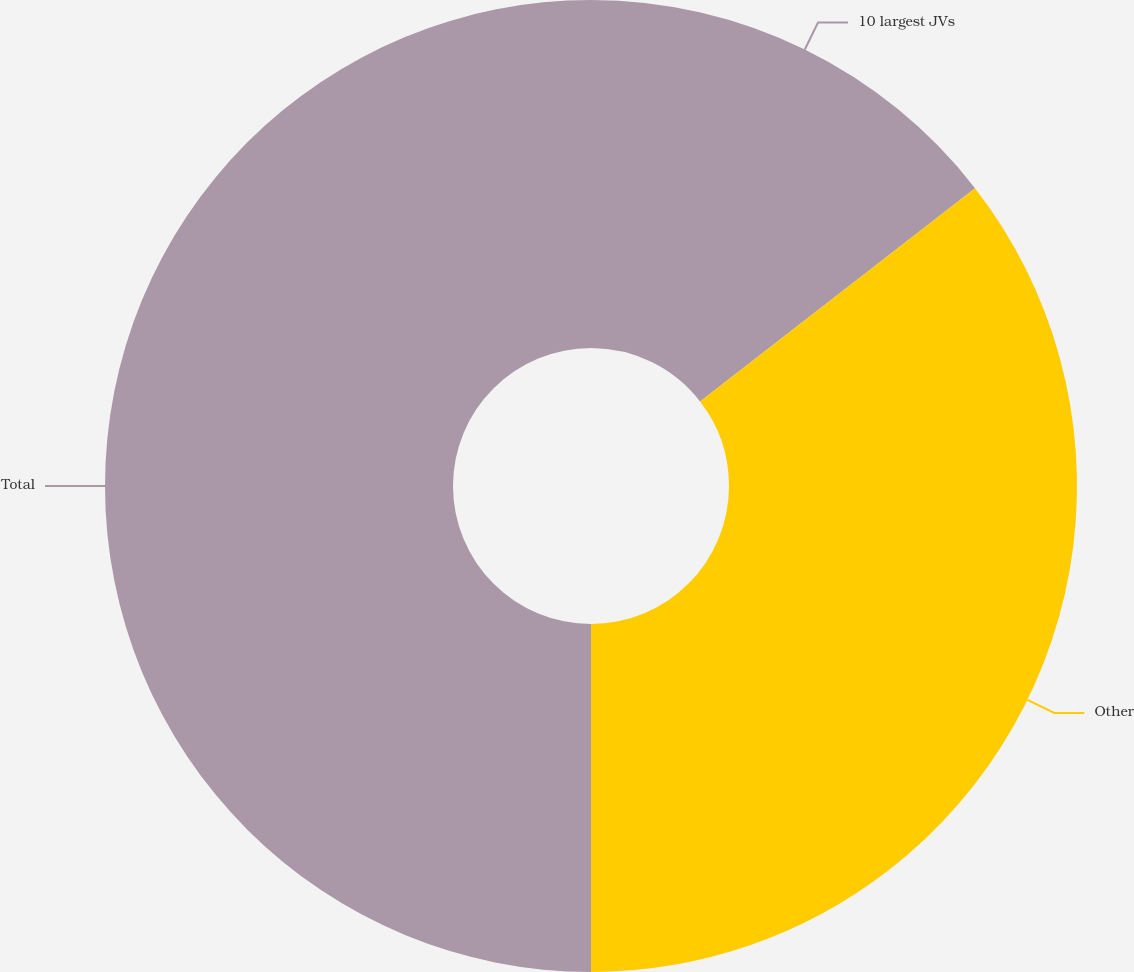Convert chart. <chart><loc_0><loc_0><loc_500><loc_500><pie_chart><fcel>10 largest JVs<fcel>Other<fcel>Total<nl><fcel>14.5%<fcel>35.5%<fcel>50.0%<nl></chart> 